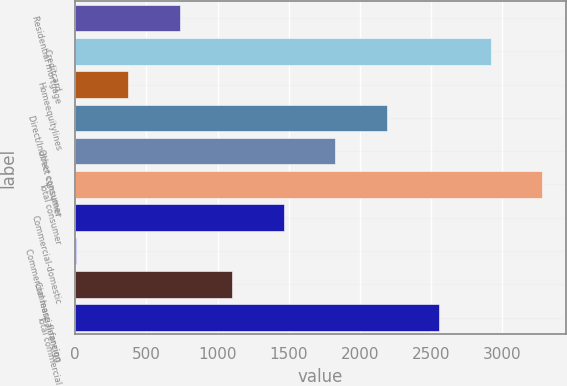Convert chart. <chart><loc_0><loc_0><loc_500><loc_500><bar_chart><fcel>Residential mortgage<fcel>Creditcard<fcel>Homeequitylines<fcel>Direct/Indirect consumer<fcel>Other consumer<fcel>Total consumer<fcel>Commercial-domestic<fcel>Commercial lease financing<fcel>Commercial-foreign<fcel>Total commercial<nl><fcel>736<fcel>2917<fcel>372.5<fcel>2190<fcel>1826.5<fcel>3281<fcel>1463<fcel>9<fcel>1099.5<fcel>2553.5<nl></chart> 